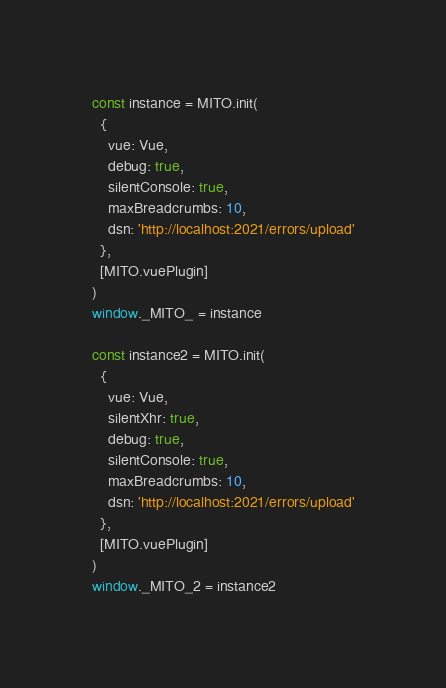Convert code to text. <code><loc_0><loc_0><loc_500><loc_500><_JavaScript_>const instance = MITO.init(
  {
    vue: Vue,
    debug: true,
    silentConsole: true,
    maxBreadcrumbs: 10,
    dsn: 'http://localhost:2021/errors/upload'
  },
  [MITO.vuePlugin]
)
window._MITO_ = instance

const instance2 = MITO.init(
  {
    vue: Vue,
    silentXhr: true,
    debug: true,
    silentConsole: true,
    maxBreadcrumbs: 10,
    dsn: 'http://localhost:2021/errors/upload'
  },
  [MITO.vuePlugin]
)
window._MITO_2 = instance2
</code> 